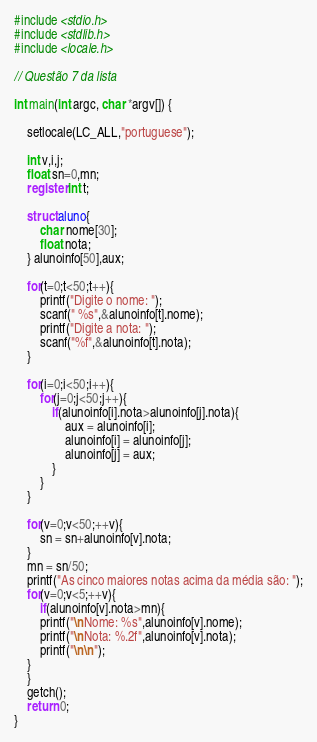<code> <loc_0><loc_0><loc_500><loc_500><_C_>#include <stdio.h>
#include <stdlib.h>
#include <locale.h>

// Questão 7 da lista

int main(int argc, char *argv[]) {

	setlocale(LC_ALL,"portuguese");

	int v,i,j;
	float sn=0,mn;
	register int t;

	struct aluno{
		char nome[30];
		float nota;
	} alunoinfo[50],aux;

	for(t=0;t<50;t++){
		printf("Digite o nome: ");
		scanf(" %s",&alunoinfo[t].nome);
		printf("Digite a nota: ");
		scanf("%f",&alunoinfo[t].nota);
	}

	for(i=0;i<50;i++){
		for(j=0;j<50;j++){
			if(alunoinfo[i].nota>alunoinfo[j].nota){
				aux = alunoinfo[i];
				alunoinfo[i] = alunoinfo[j];
				alunoinfo[j] = aux;
			}
		}
	}

	for(v=0;v<50;++v){
		sn = sn+alunoinfo[v].nota;
	}
	mn = sn/50;
	printf("As cinco maiores notas acima da média são: ");
	for(v=0;v<5;++v){
		if(alunoinfo[v].nota>mn){
		printf("\nNome: %s",alunoinfo[v].nome);
		printf("\nNota: %.2f",alunoinfo[v].nota);
		printf("\n\n");
	}
	}
	getch();
	return 0;
}
</code> 